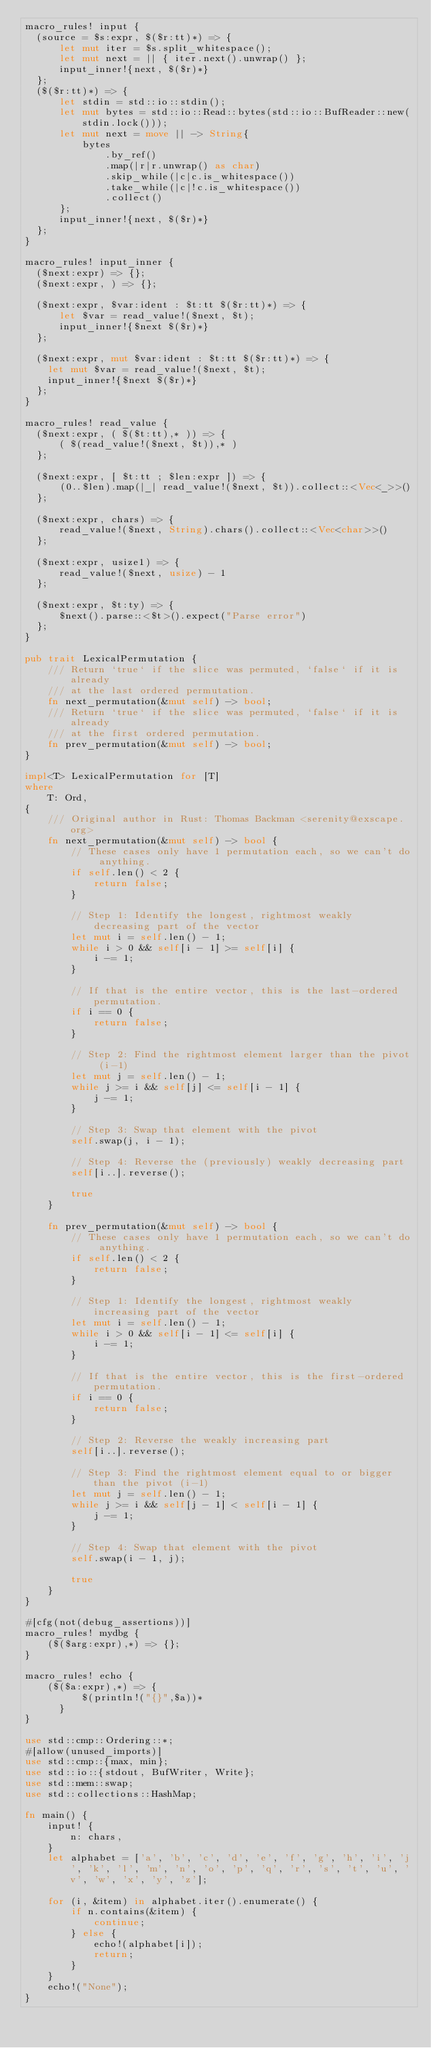Convert code to text. <code><loc_0><loc_0><loc_500><loc_500><_Rust_>macro_rules! input {
  (source = $s:expr, $($r:tt)*) => {
      let mut iter = $s.split_whitespace();
      let mut next = || { iter.next().unwrap() };
      input_inner!{next, $($r)*}
  };
  ($($r:tt)*) => {
      let stdin = std::io::stdin();
      let mut bytes = std::io::Read::bytes(std::io::BufReader::new(stdin.lock()));
      let mut next = move || -> String{
          bytes
              .by_ref()
              .map(|r|r.unwrap() as char)
              .skip_while(|c|c.is_whitespace())
              .take_while(|c|!c.is_whitespace())
              .collect()
      };
      input_inner!{next, $($r)*}
  };
}

macro_rules! input_inner {
  ($next:expr) => {};
  ($next:expr, ) => {};

  ($next:expr, $var:ident : $t:tt $($r:tt)*) => {
      let $var = read_value!($next, $t);
      input_inner!{$next $($r)*}
  };

  ($next:expr, mut $var:ident : $t:tt $($r:tt)*) => {
    let mut $var = read_value!($next, $t);
    input_inner!{$next $($r)*}
  };
}

macro_rules! read_value {
  ($next:expr, ( $($t:tt),* )) => {
      ( $(read_value!($next, $t)),* )
  };

  ($next:expr, [ $t:tt ; $len:expr ]) => {
      (0..$len).map(|_| read_value!($next, $t)).collect::<Vec<_>>()
  };

  ($next:expr, chars) => {
      read_value!($next, String).chars().collect::<Vec<char>>()
  };

  ($next:expr, usize1) => {
      read_value!($next, usize) - 1
  };

  ($next:expr, $t:ty) => {
      $next().parse::<$t>().expect("Parse error")
  };
}

pub trait LexicalPermutation {
    /// Return `true` if the slice was permuted, `false` if it is already
    /// at the last ordered permutation.
    fn next_permutation(&mut self) -> bool;
    /// Return `true` if the slice was permuted, `false` if it is already
    /// at the first ordered permutation.
    fn prev_permutation(&mut self) -> bool;
}

impl<T> LexicalPermutation for [T]
where
    T: Ord,
{
    /// Original author in Rust: Thomas Backman <serenity@exscape.org>
    fn next_permutation(&mut self) -> bool {
        // These cases only have 1 permutation each, so we can't do anything.
        if self.len() < 2 {
            return false;
        }

        // Step 1: Identify the longest, rightmost weakly decreasing part of the vector
        let mut i = self.len() - 1;
        while i > 0 && self[i - 1] >= self[i] {
            i -= 1;
        }

        // If that is the entire vector, this is the last-ordered permutation.
        if i == 0 {
            return false;
        }

        // Step 2: Find the rightmost element larger than the pivot (i-1)
        let mut j = self.len() - 1;
        while j >= i && self[j] <= self[i - 1] {
            j -= 1;
        }

        // Step 3: Swap that element with the pivot
        self.swap(j, i - 1);

        // Step 4: Reverse the (previously) weakly decreasing part
        self[i..].reverse();

        true
    }

    fn prev_permutation(&mut self) -> bool {
        // These cases only have 1 permutation each, so we can't do anything.
        if self.len() < 2 {
            return false;
        }

        // Step 1: Identify the longest, rightmost weakly increasing part of the vector
        let mut i = self.len() - 1;
        while i > 0 && self[i - 1] <= self[i] {
            i -= 1;
        }

        // If that is the entire vector, this is the first-ordered permutation.
        if i == 0 {
            return false;
        }

        // Step 2: Reverse the weakly increasing part
        self[i..].reverse();

        // Step 3: Find the rightmost element equal to or bigger than the pivot (i-1)
        let mut j = self.len() - 1;
        while j >= i && self[j - 1] < self[i - 1] {
            j -= 1;
        }

        // Step 4: Swap that element with the pivot
        self.swap(i - 1, j);

        true
    }
}

#[cfg(not(debug_assertions))]
macro_rules! mydbg {
    ($($arg:expr),*) => {};
}

macro_rules! echo {
    ($($a:expr),*) => {
          $(println!("{}",$a))*
      }
}

use std::cmp::Ordering::*;
#[allow(unused_imports)]
use std::cmp::{max, min};
use std::io::{stdout, BufWriter, Write};
use std::mem::swap;
use std::collections::HashMap;

fn main() {
    input! {
        n: chars,
    }
    let alphabet = ['a', 'b', 'c', 'd', 'e', 'f', 'g', 'h', 'i', 'j', 'k', 'l', 'm', 'n', 'o', 'p', 'q', 'r', 's', 't', 'u', 'v', 'w', 'x', 'y', 'z'];

    for (i, &item) in alphabet.iter().enumerate() {
        if n.contains(&item) {
            continue;
        } else {
            echo!(alphabet[i]);
            return;
        }
    }
    echo!("None");
}</code> 